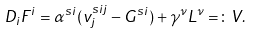<formula> <loc_0><loc_0><loc_500><loc_500>D _ { i } F ^ { i } = \alpha ^ { s i } ( v ^ { s i j } _ { j } - G ^ { s i } ) + \gamma ^ { \nu } L ^ { \nu } = \colon V .</formula> 